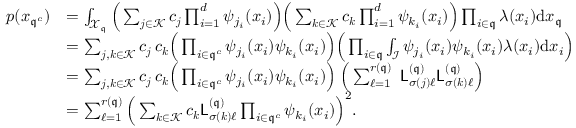Convert formula to latex. <formula><loc_0><loc_0><loc_500><loc_500>\begin{array} { r l } { p ( { \boldsymbol x } _ { { \mathfrak { q } } ^ { c } } ) } & { = \int _ { \mathcal { X } _ { \mathfrak { q } } } \left ( \sum _ { { \boldsymbol j } \in \mathcal { K } } c _ { \boldsymbol j } \prod _ { i = 1 } ^ { d } \psi _ { j _ { i } } ( x _ { i } ) \right ) \left ( \sum _ { { \boldsymbol k } \in \mathcal { K } } c _ { \boldsymbol k } \prod _ { i = 1 } ^ { d } \psi _ { k _ { i } } ( x _ { i } ) \right ) \prod _ { i \in { \mathfrak { q } } } \lambda ( x _ { i } ) { d } { \boldsymbol x } _ { \mathfrak { q } } } \\ & { = \sum _ { { \boldsymbol j } , { \boldsymbol k } \in \mathcal { K } } c _ { \boldsymbol j } \, c _ { \boldsymbol k } \left ( \prod _ { i \in { \mathfrak { q } } ^ { c } } \psi _ { j _ { i } } ( x _ { i } ) \psi _ { k _ { i } } ( x _ { i } ) \right ) \left ( \prod _ { i \in { \mathfrak { q } } } \int _ { \mathcal { I } } \psi _ { j _ { i } } ( x _ { i } ) \psi _ { k _ { i } } ( x _ { i } ) \lambda ( x _ { i } ) { d } x _ { i } \right ) } \\ & { = \sum _ { { \boldsymbol j } , { \boldsymbol k } \in \mathcal { K } } c _ { \boldsymbol j } \, c _ { \boldsymbol k } \left ( \prod _ { i \in { \mathfrak { q } } ^ { c } } \psi _ { j _ { i } } ( x _ { i } ) \psi _ { k _ { i } } ( x _ { i } ) \right ) \, \left ( \sum _ { \ell = 1 } ^ { r ( { \mathfrak { q } } ) } \, \mathsf L _ { \sigma ( { \boldsymbol j } ) \ell } ^ { ( { \mathfrak { q } } ) } \mathsf L _ { \sigma ( { \boldsymbol k } ) \ell } ^ { ( { \mathfrak { q } } ) } \right ) } \\ & { = \sum _ { \ell = 1 } ^ { r ( { \mathfrak { q } } ) } \left ( \sum _ { { \boldsymbol k } \in \mathcal { K } } c _ { \boldsymbol k } \mathsf L _ { \sigma ( { \boldsymbol k } ) \ell } ^ { ( { \mathfrak { q } } ) } \prod _ { i \in { \mathfrak { q } } ^ { c } } \psi _ { k _ { i } } ( x _ { i } ) \right ) ^ { 2 } . } \end{array}</formula> 